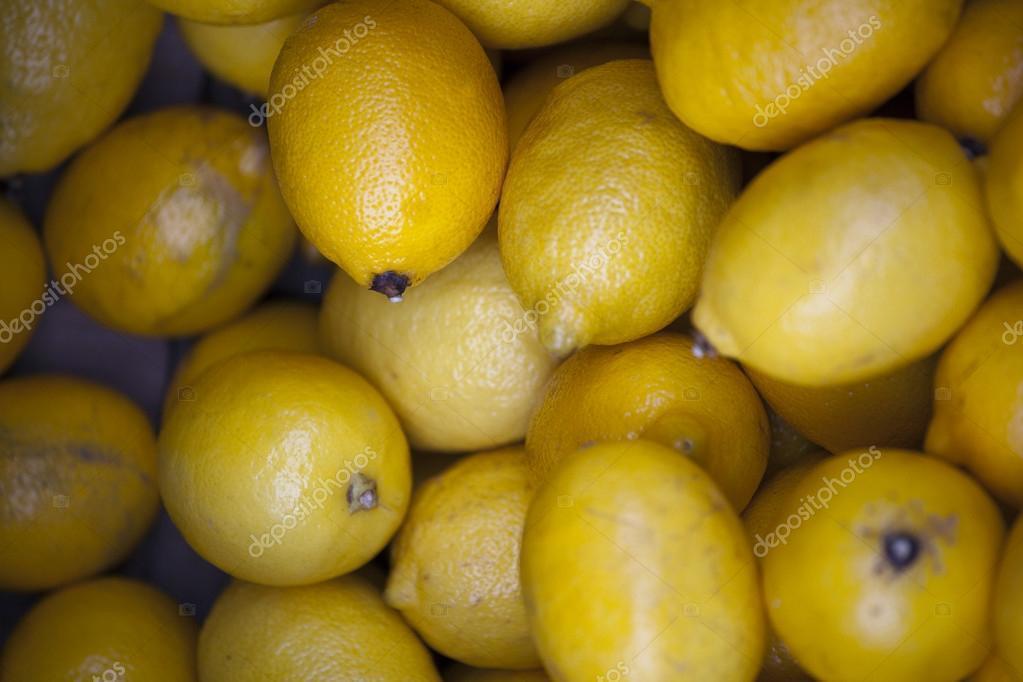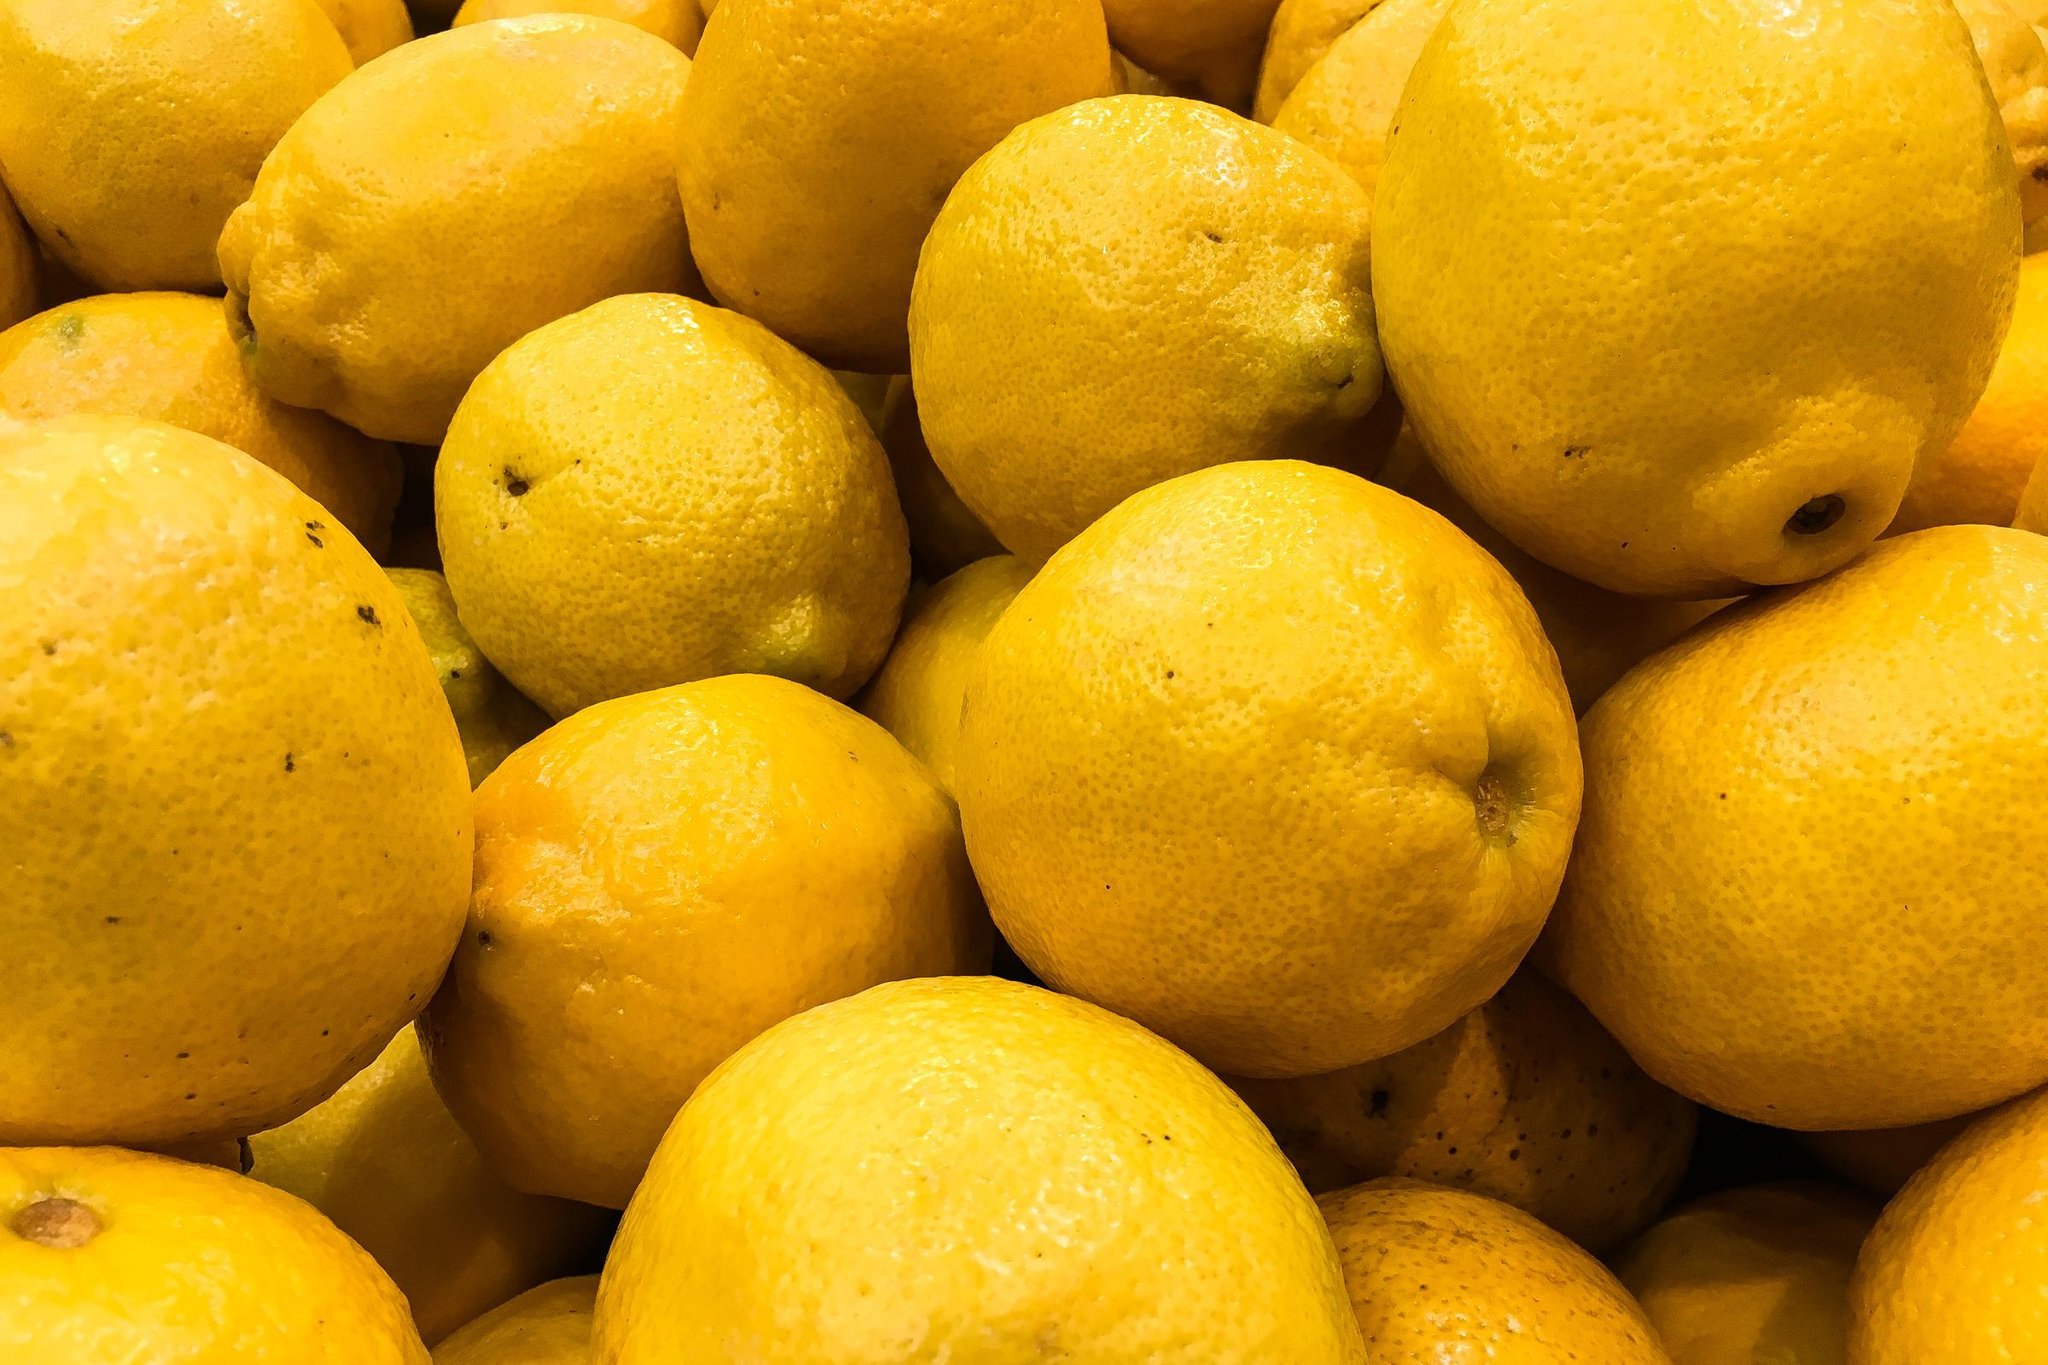The first image is the image on the left, the second image is the image on the right. For the images displayed, is the sentence "In at least one image ther is a pile of lemon with two on the right side on top of each other facing forward right." factually correct? Answer yes or no. No. The first image is the image on the left, the second image is the image on the right. For the images shown, is this caption "In one of the images, a pile of lemons has a dark shadow on the left side." true? Answer yes or no. Yes. 